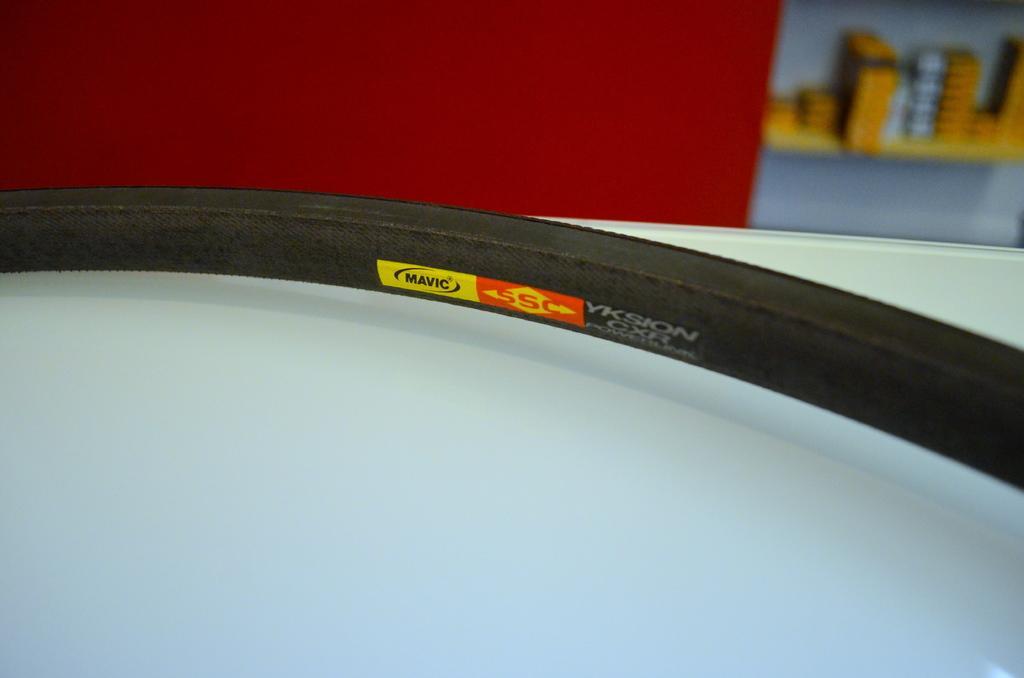Could you give a brief overview of what you see in this image? In this picture we can see a Tyre on a white surface and in the background we can see some objects. 